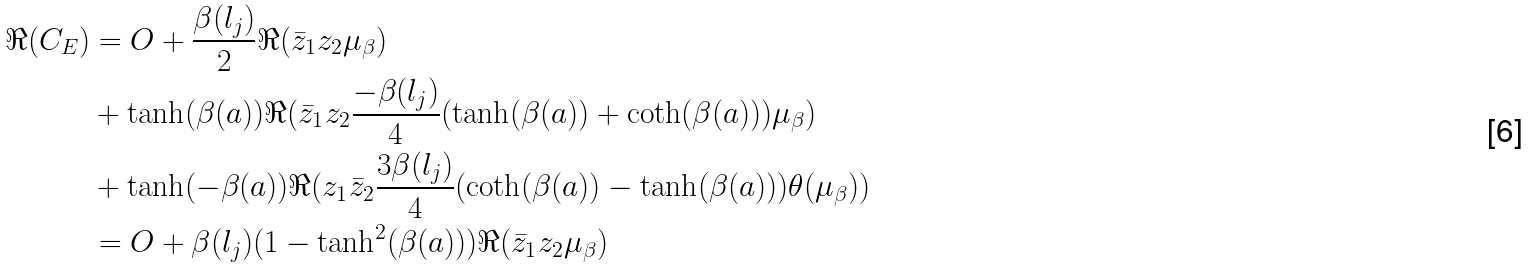Convert formula to latex. <formula><loc_0><loc_0><loc_500><loc_500>\Re ( C _ { E } ) & = O + \frac { \beta ( l _ { j } ) } { 2 } \Re ( \bar { z } _ { 1 } z _ { 2 } \mu _ { \beta } ) \\ & + \tanh ( \beta ( a ) ) \Re ( \bar { z } _ { 1 } z _ { 2 } \frac { - \beta ( l _ { j } ) } { 4 } ( \tanh ( \beta ( a ) ) + \coth ( \beta ( a ) ) ) \mu _ { \beta } ) \\ & + \tanh ( - \beta ( a ) ) \Re ( z _ { 1 } \bar { z } _ { 2 } \frac { 3 \beta ( l _ { j } ) } { 4 } ( \coth ( \beta ( a ) ) - \tanh ( \beta ( a ) ) ) \theta ( \mu _ { \beta } ) ) \\ & = O + \beta ( l _ { j } ) ( 1 - \tanh ^ { 2 } ( \beta ( a ) ) ) \Re ( \bar { z } _ { 1 } z _ { 2 } \mu _ { \beta } )</formula> 